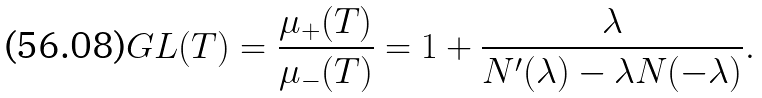<formula> <loc_0><loc_0><loc_500><loc_500>G L ( T ) = \frac { \mu _ { + } ( T ) } { \mu _ { - } ( T ) } = 1 + \frac { \lambda } { N ^ { \prime } ( \lambda ) - \lambda N ( - \lambda ) } .</formula> 